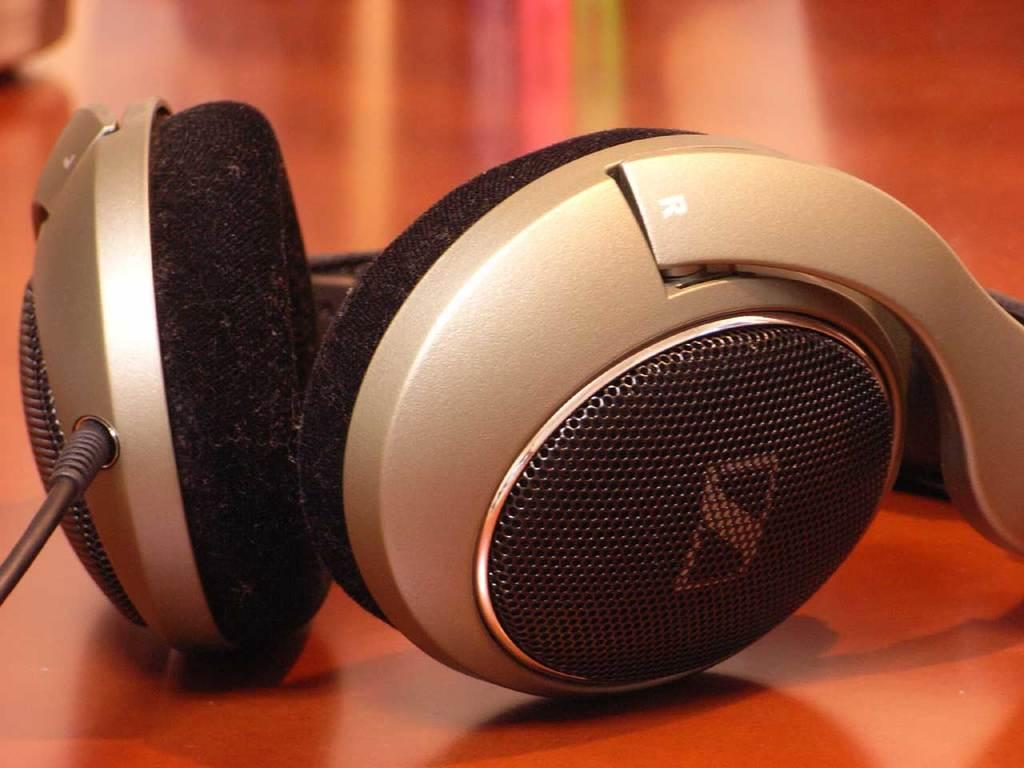What type of device is visible in the image? There is a headset in the image. Can you describe any additional features of the headset? A: There is a wire in the image, which is likely connected to the headset. What month is depicted in the image? There is no month depicted in the image; it only features a headset and a wire. What type of map can be seen in the image? There is no map present in the image. 